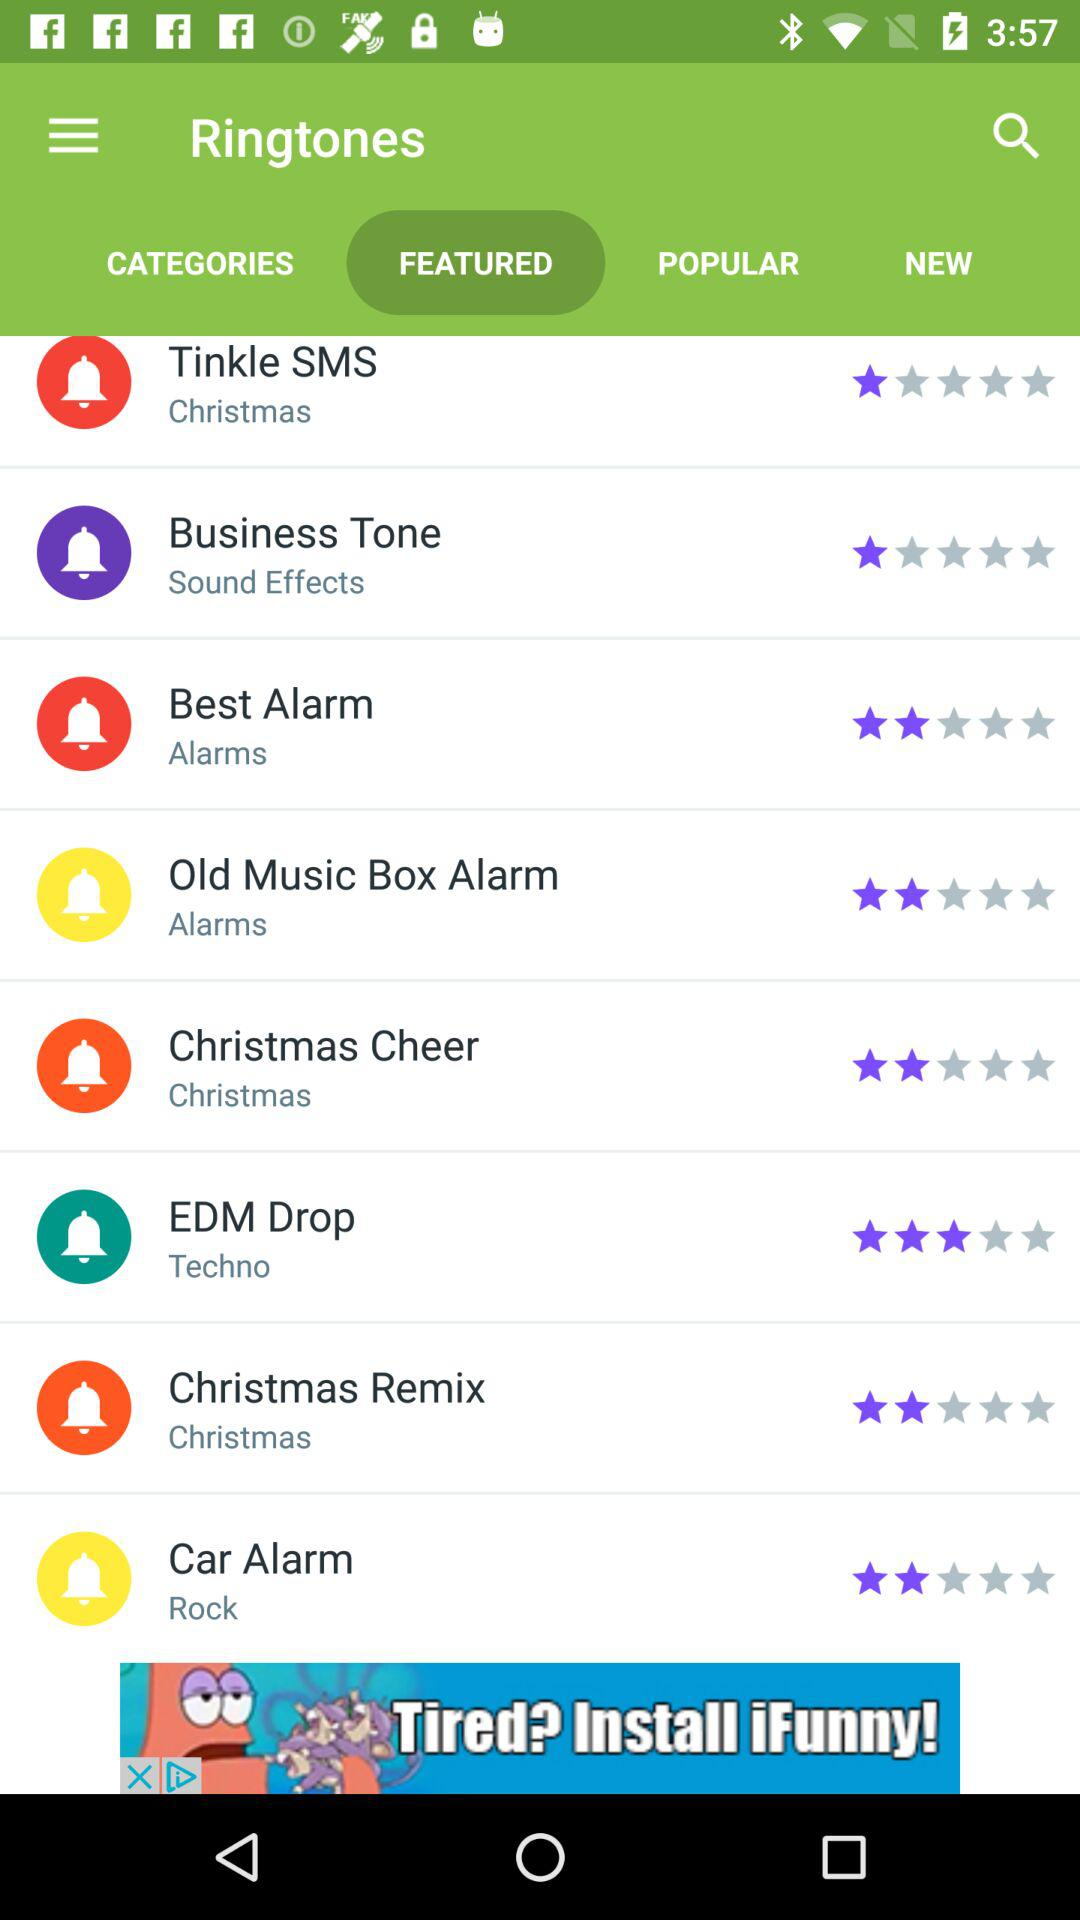Which tab is selected? The selected tab is "FEATURED". 